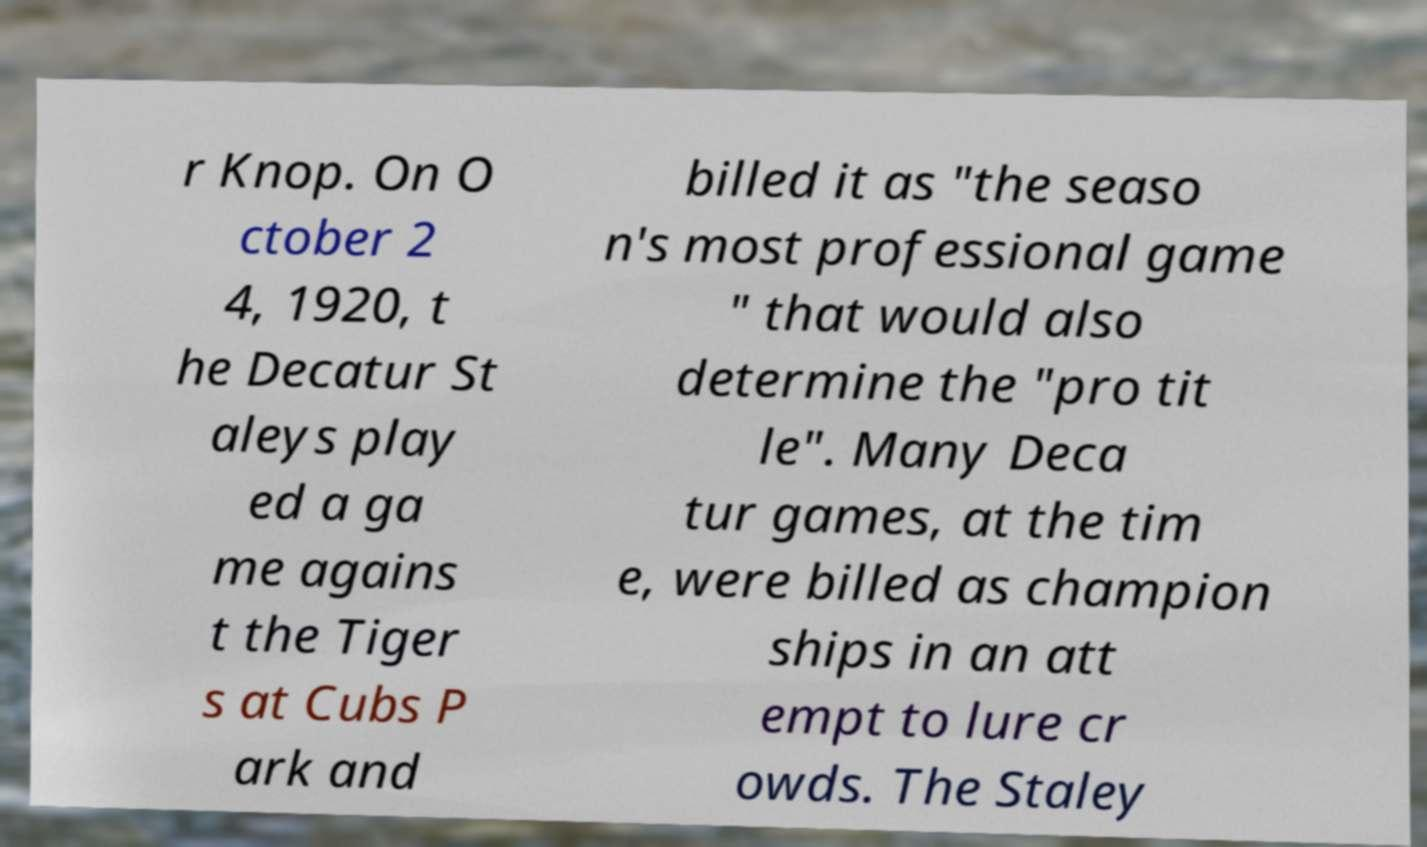Please identify and transcribe the text found in this image. r Knop. On O ctober 2 4, 1920, t he Decatur St aleys play ed a ga me agains t the Tiger s at Cubs P ark and billed it as "the seaso n's most professional game " that would also determine the "pro tit le". Many Deca tur games, at the tim e, were billed as champion ships in an att empt to lure cr owds. The Staley 